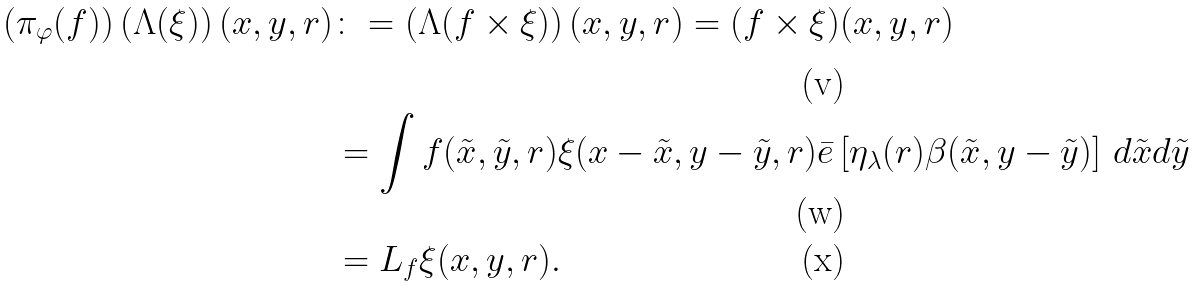<formula> <loc_0><loc_0><loc_500><loc_500>\left ( \pi _ { \varphi } ( f ) \right ) \left ( \Lambda ( \xi ) \right ) ( x , y , r ) & \colon = \left ( \Lambda ( f \times \xi ) \right ) ( x , y , r ) = ( f \times \xi ) ( x , y , r ) \\ & = \int f ( \tilde { x } , \tilde { y } , r ) \xi ( x - \tilde { x } , y - \tilde { y } , r ) \bar { e } \left [ \eta _ { \lambda } ( r ) \beta ( \tilde { x } , y - \tilde { y } ) \right ] \, d \tilde { x } d \tilde { y } \\ & = L _ { f } \xi ( x , y , r ) .</formula> 